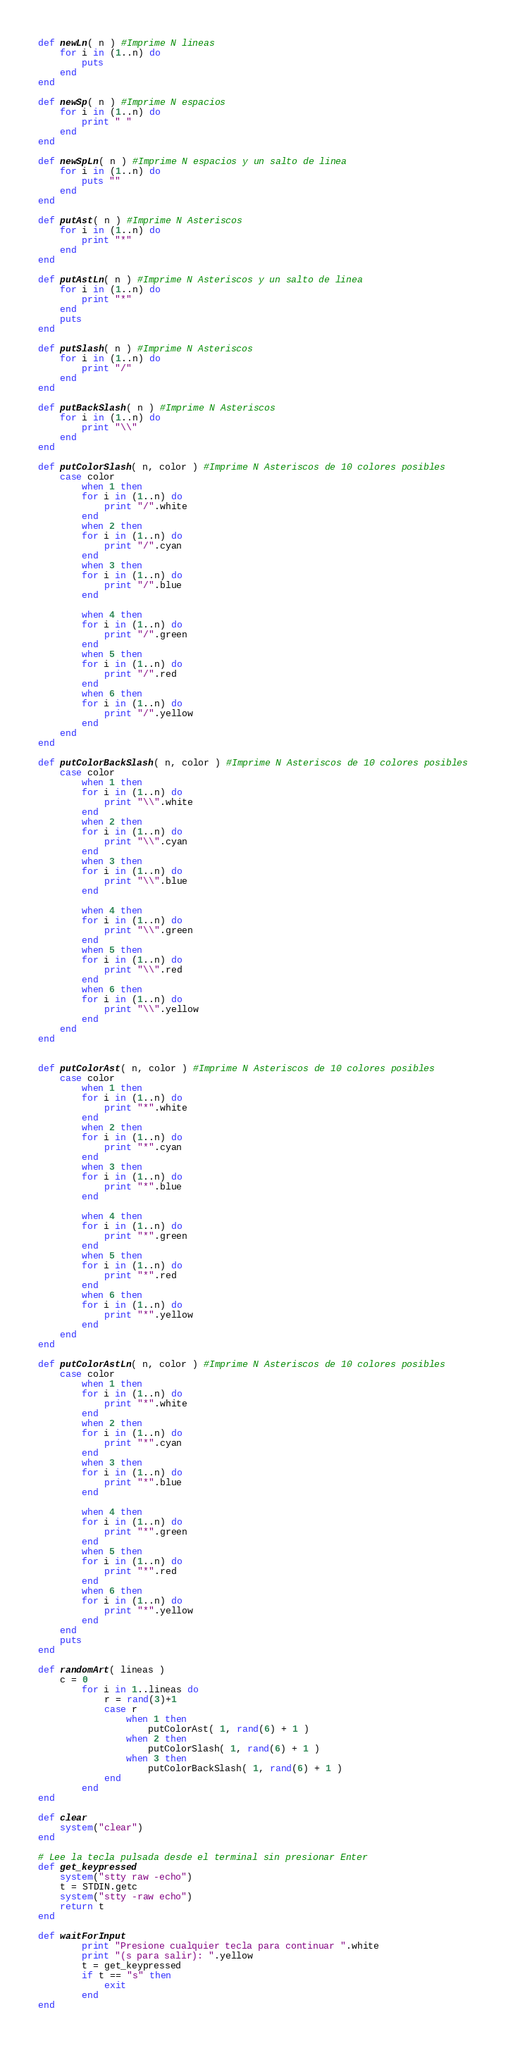Convert code to text. <code><loc_0><loc_0><loc_500><loc_500><_Ruby_>
def newLn( n ) #Imprime N lineas
	for i in (1..n) do
		puts
	end
end

def newSp( n ) #Imprime N espacios
	for i in (1..n) do
		print " "
	end
end

def newSpLn( n ) #Imprime N espacios y un salto de linea
	for i in (1..n) do
		puts ""
	end
end

def putAst( n ) #Imprime N Asteriscos 
	for i in (1..n) do
		print "*"
	end
end

def putAstLn( n ) #Imprime N Asteriscos y un salto de linea
	for i in (1..n) do
		print "*"
	end
	puts
end

def putSlash( n ) #Imprime N Asteriscos 
	for i in (1..n) do
		print "/"
	end
end

def putBackSlash( n ) #Imprime N Asteriscos 
	for i in (1..n) do
		print "\\"
	end
end

def putColorSlash( n, color ) #Imprime N Asteriscos de 10 colores posibles
	case color 
		when 1 then
		for i in (1..n) do
			print "/".white
		end
		when 2 then
		for i in (1..n) do
			print "/".cyan
		end
		when 3 then
		for i in (1..n) do
			print "/".blue
		end
		
		when 4 then
		for i in (1..n) do
			print "/".green
		end
		when 5 then
		for i in (1..n) do
			print "/".red
		end
		when 6 then
		for i in (1..n) do
			print "/".yellow
		end
	end	
end

def putColorBackSlash( n, color ) #Imprime N Asteriscos de 10 colores posibles
	case color 
		when 1 then
		for i in (1..n) do
			print "\\".white
		end
		when 2 then
		for i in (1..n) do
			print "\\".cyan
		end
		when 3 then
		for i in (1..n) do
			print "\\".blue
		end
		
		when 4 then
		for i in (1..n) do
			print "\\".green
		end
		when 5 then
		for i in (1..n) do
			print "\\".red
		end
		when 6 then
		for i in (1..n) do
			print "\\".yellow
		end
	end	
end


def putColorAst( n, color ) #Imprime N Asteriscos de 10 colores posibles
	case color 
		when 1 then
		for i in (1..n) do
			print "*".white
		end
		when 2 then
		for i in (1..n) do
			print "*".cyan
		end
		when 3 then
		for i in (1..n) do
			print "*".blue
		end
		
		when 4 then
		for i in (1..n) do
			print "*".green
		end
		when 5 then
		for i in (1..n) do
			print "*".red
		end
		when 6 then
		for i in (1..n) do
			print "*".yellow
		end
	end	
end

def putColorAstLn( n, color ) #Imprime N Asteriscos de 10 colores posibles
	case color 
		when 1 then
		for i in (1..n) do
			print "*".white
		end
		when 2 then
		for i in (1..n) do
			print "*".cyan
		end
		when 3 then
		for i in (1..n) do
			print "*".blue
		end
		
		when 4 then
		for i in (1..n) do
			print "*".green
		end
		when 5 then
		for i in (1..n) do
			print "*".red
		end
		when 6 then
		for i in (1..n) do
			print "*".yellow
		end
	end	
	puts
end

def randomArt( lineas )
	c = 0	
		for i in 1..lineas do
			r = rand(3)+1
			case r
				when 1 then
					putColorAst( 1, rand(6) + 1 )
				when 2 then
					putColorSlash( 1, rand(6) + 1 )
				when 3 then
					putColorBackSlash( 1, rand(6) + 1 )
			end
		end	
end		

def clear
	system("clear")
end

# Lee la tecla pulsada desde el terminal sin presionar Enter
def get_keypressed
	system("stty raw -echo")
	t = STDIN.getc
	system("stty -raw echo")
	return t
end

def waitForInput
		print "Presione cualquier tecla para continuar ".white
		print "(s para salir): ".yellow
		t = get_keypressed
		if t == "s" then
			exit
		end
end</code> 